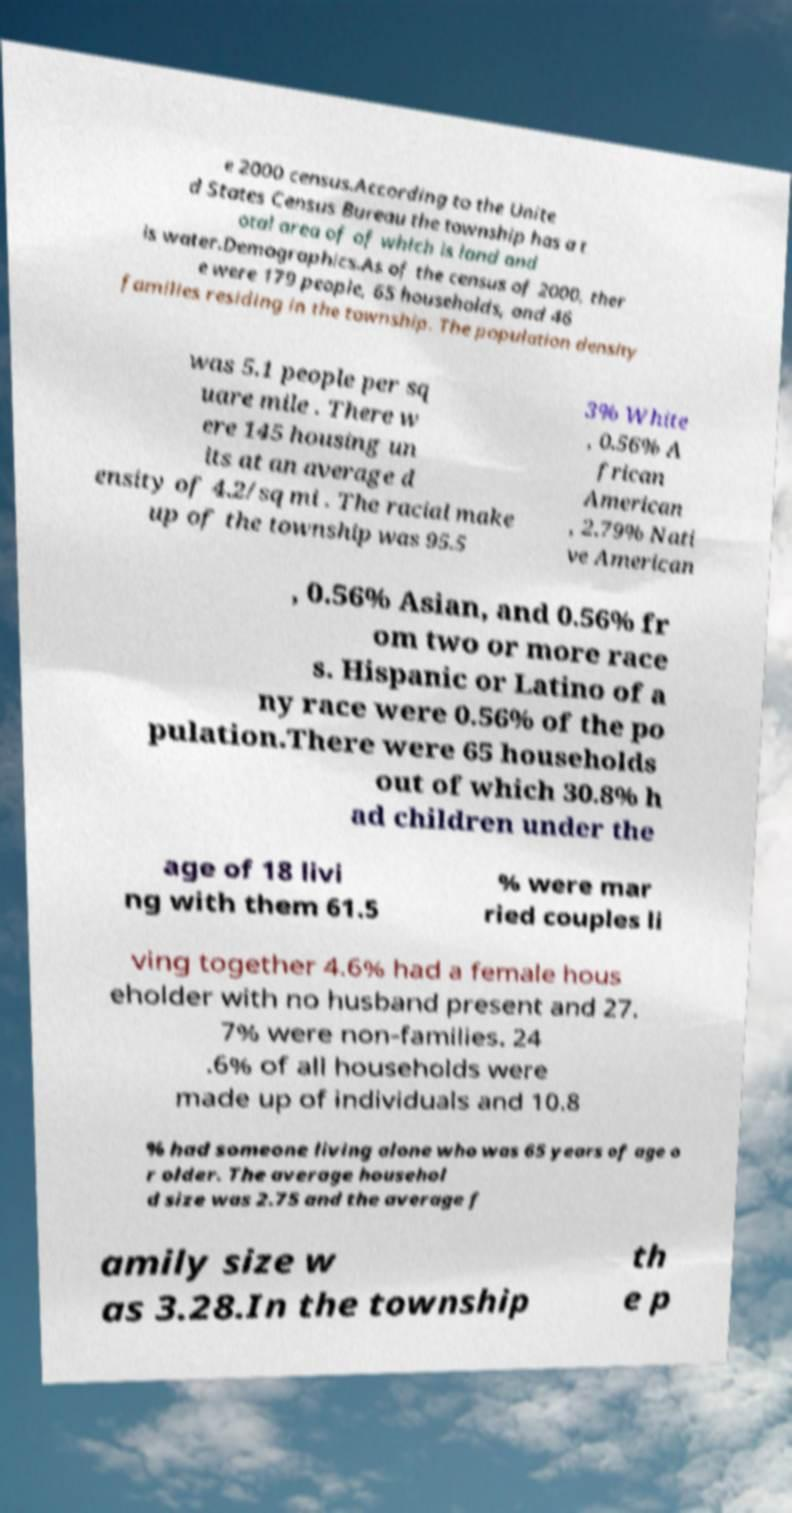Can you read and provide the text displayed in the image?This photo seems to have some interesting text. Can you extract and type it out for me? e 2000 census.According to the Unite d States Census Bureau the township has a t otal area of of which is land and is water.Demographics.As of the census of 2000, ther e were 179 people, 65 households, and 46 families residing in the township. The population density was 5.1 people per sq uare mile . There w ere 145 housing un its at an average d ensity of 4.2/sq mi . The racial make up of the township was 95.5 3% White , 0.56% A frican American , 2.79% Nati ve American , 0.56% Asian, and 0.56% fr om two or more race s. Hispanic or Latino of a ny race were 0.56% of the po pulation.There were 65 households out of which 30.8% h ad children under the age of 18 livi ng with them 61.5 % were mar ried couples li ving together 4.6% had a female hous eholder with no husband present and 27. 7% were non-families. 24 .6% of all households were made up of individuals and 10.8 % had someone living alone who was 65 years of age o r older. The average househol d size was 2.75 and the average f amily size w as 3.28.In the township th e p 